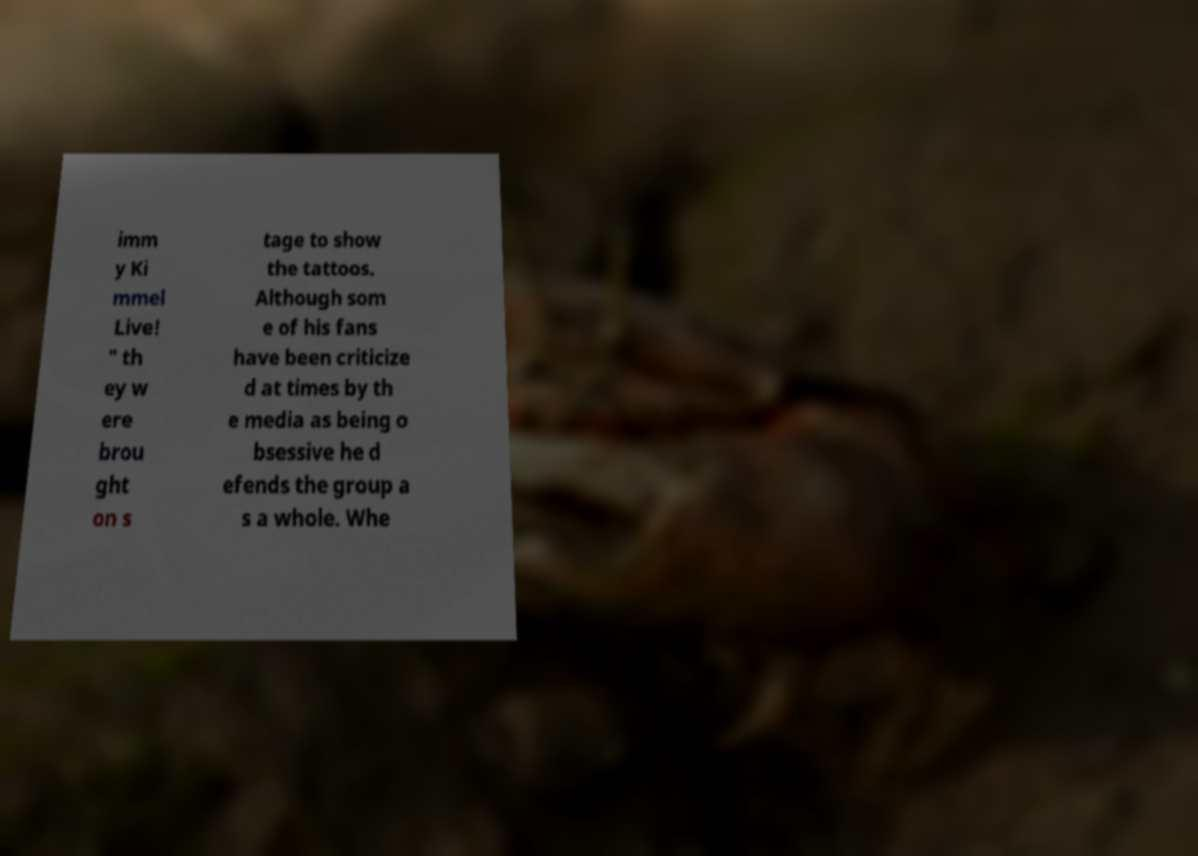I need the written content from this picture converted into text. Can you do that? imm y Ki mmel Live! " th ey w ere brou ght on s tage to show the tattoos. Although som e of his fans have been criticize d at times by th e media as being o bsessive he d efends the group a s a whole. Whe 